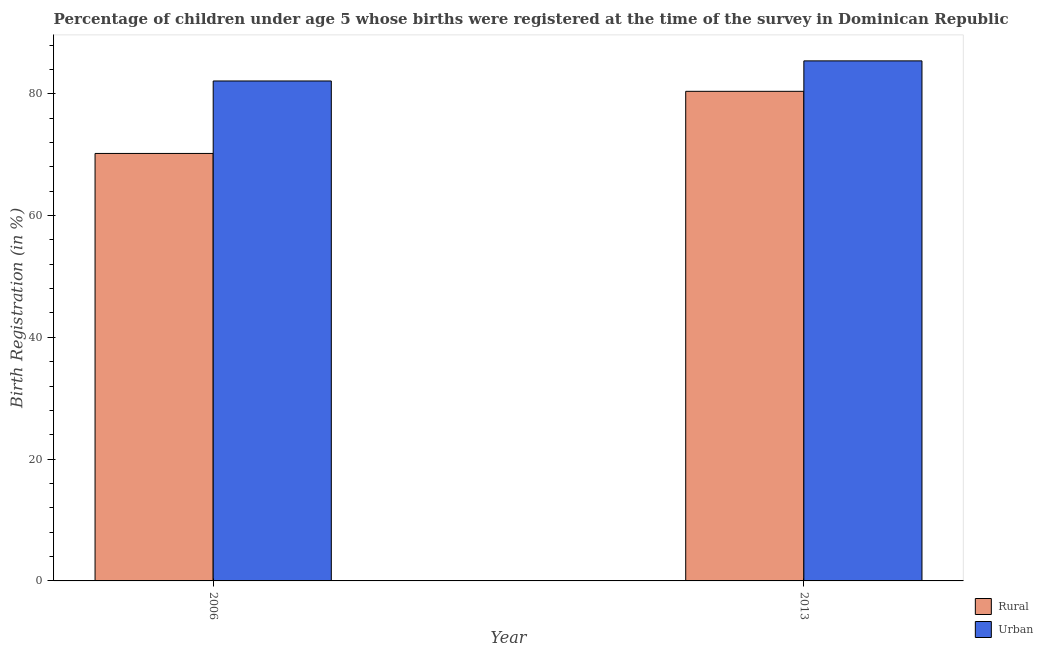How many groups of bars are there?
Your response must be concise. 2. Are the number of bars per tick equal to the number of legend labels?
Ensure brevity in your answer.  Yes. Are the number of bars on each tick of the X-axis equal?
Provide a succinct answer. Yes. How many bars are there on the 1st tick from the right?
Ensure brevity in your answer.  2. What is the label of the 1st group of bars from the left?
Provide a short and direct response. 2006. What is the rural birth registration in 2006?
Provide a succinct answer. 70.2. Across all years, what is the maximum rural birth registration?
Your answer should be very brief. 80.4. Across all years, what is the minimum rural birth registration?
Offer a terse response. 70.2. In which year was the rural birth registration maximum?
Provide a succinct answer. 2013. In which year was the urban birth registration minimum?
Your answer should be very brief. 2006. What is the total rural birth registration in the graph?
Give a very brief answer. 150.6. What is the difference between the urban birth registration in 2006 and that in 2013?
Make the answer very short. -3.3. What is the difference between the urban birth registration in 2013 and the rural birth registration in 2006?
Offer a very short reply. 3.3. What is the average rural birth registration per year?
Offer a very short reply. 75.3. In the year 2013, what is the difference between the urban birth registration and rural birth registration?
Provide a succinct answer. 0. In how many years, is the urban birth registration greater than 40 %?
Your answer should be compact. 2. What is the ratio of the rural birth registration in 2006 to that in 2013?
Your response must be concise. 0.87. In how many years, is the urban birth registration greater than the average urban birth registration taken over all years?
Make the answer very short. 1. What does the 2nd bar from the left in 2006 represents?
Offer a terse response. Urban. What does the 1st bar from the right in 2013 represents?
Keep it short and to the point. Urban. Are all the bars in the graph horizontal?
Ensure brevity in your answer.  No. How many years are there in the graph?
Provide a short and direct response. 2. Are the values on the major ticks of Y-axis written in scientific E-notation?
Give a very brief answer. No. Does the graph contain any zero values?
Your response must be concise. No. Does the graph contain grids?
Offer a very short reply. No. How many legend labels are there?
Give a very brief answer. 2. How are the legend labels stacked?
Give a very brief answer. Vertical. What is the title of the graph?
Make the answer very short. Percentage of children under age 5 whose births were registered at the time of the survey in Dominican Republic. Does "External balance on goods" appear as one of the legend labels in the graph?
Keep it short and to the point. No. What is the label or title of the Y-axis?
Provide a succinct answer. Birth Registration (in %). What is the Birth Registration (in %) in Rural in 2006?
Keep it short and to the point. 70.2. What is the Birth Registration (in %) in Urban in 2006?
Keep it short and to the point. 82.1. What is the Birth Registration (in %) in Rural in 2013?
Give a very brief answer. 80.4. What is the Birth Registration (in %) of Urban in 2013?
Provide a short and direct response. 85.4. Across all years, what is the maximum Birth Registration (in %) in Rural?
Provide a succinct answer. 80.4. Across all years, what is the maximum Birth Registration (in %) of Urban?
Your answer should be very brief. 85.4. Across all years, what is the minimum Birth Registration (in %) in Rural?
Provide a succinct answer. 70.2. Across all years, what is the minimum Birth Registration (in %) of Urban?
Offer a terse response. 82.1. What is the total Birth Registration (in %) of Rural in the graph?
Give a very brief answer. 150.6. What is the total Birth Registration (in %) of Urban in the graph?
Offer a terse response. 167.5. What is the difference between the Birth Registration (in %) of Rural in 2006 and the Birth Registration (in %) of Urban in 2013?
Give a very brief answer. -15.2. What is the average Birth Registration (in %) of Rural per year?
Provide a succinct answer. 75.3. What is the average Birth Registration (in %) in Urban per year?
Provide a succinct answer. 83.75. In the year 2013, what is the difference between the Birth Registration (in %) of Rural and Birth Registration (in %) of Urban?
Give a very brief answer. -5. What is the ratio of the Birth Registration (in %) of Rural in 2006 to that in 2013?
Keep it short and to the point. 0.87. What is the ratio of the Birth Registration (in %) in Urban in 2006 to that in 2013?
Keep it short and to the point. 0.96. What is the difference between the highest and the lowest Birth Registration (in %) in Rural?
Keep it short and to the point. 10.2. 